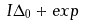Convert formula to latex. <formula><loc_0><loc_0><loc_500><loc_500>I \Delta _ { 0 } + e x p</formula> 